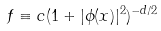<formula> <loc_0><loc_0><loc_500><loc_500>f \equiv c ( 1 + | \phi ( x ) | ^ { 2 } ) ^ { - d / 2 }</formula> 